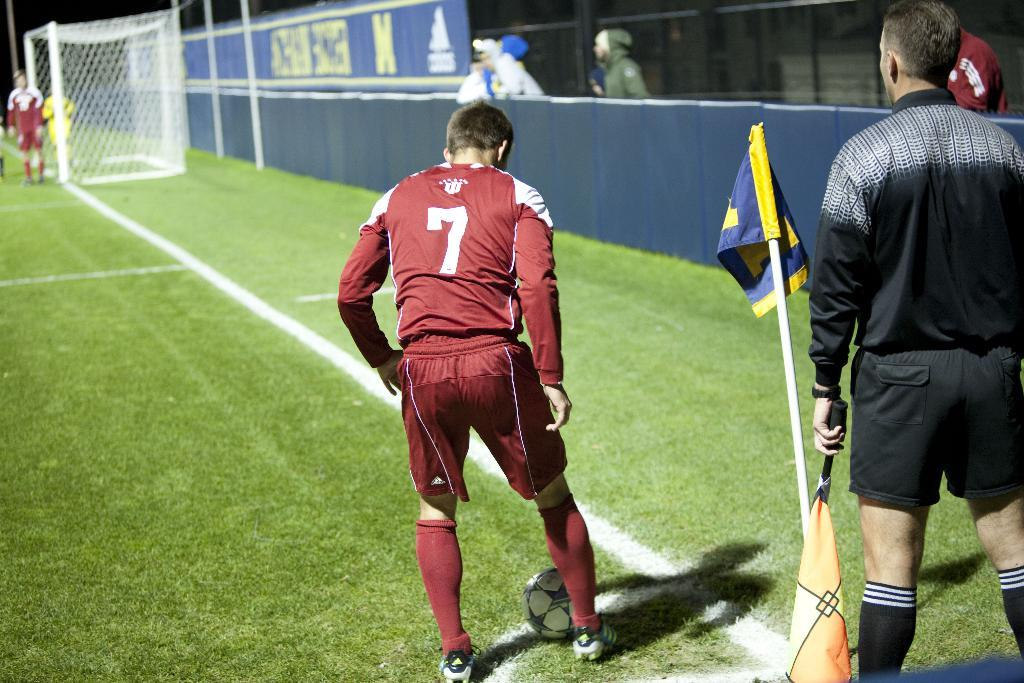What is happening in the image involving the persons? There are persons standing in the image. What type of vegetation can be seen in the image? There is new grass visible in the image. What is the flag being used for in the image? There is a flag with a stand in the image, and a person is holding the flag. What object can be seen in the image that might be used for playing? There is a ball in the image. What type of locket can be seen around the neck of the person holding the flag? There is no locket visible around the neck of the person holding the flag in the image. How many lizards are present in the image? There are no lizards present in the image. 